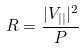Convert formula to latex. <formula><loc_0><loc_0><loc_500><loc_500>R = \frac { | V _ { | | } | ^ { 2 } } { P }</formula> 